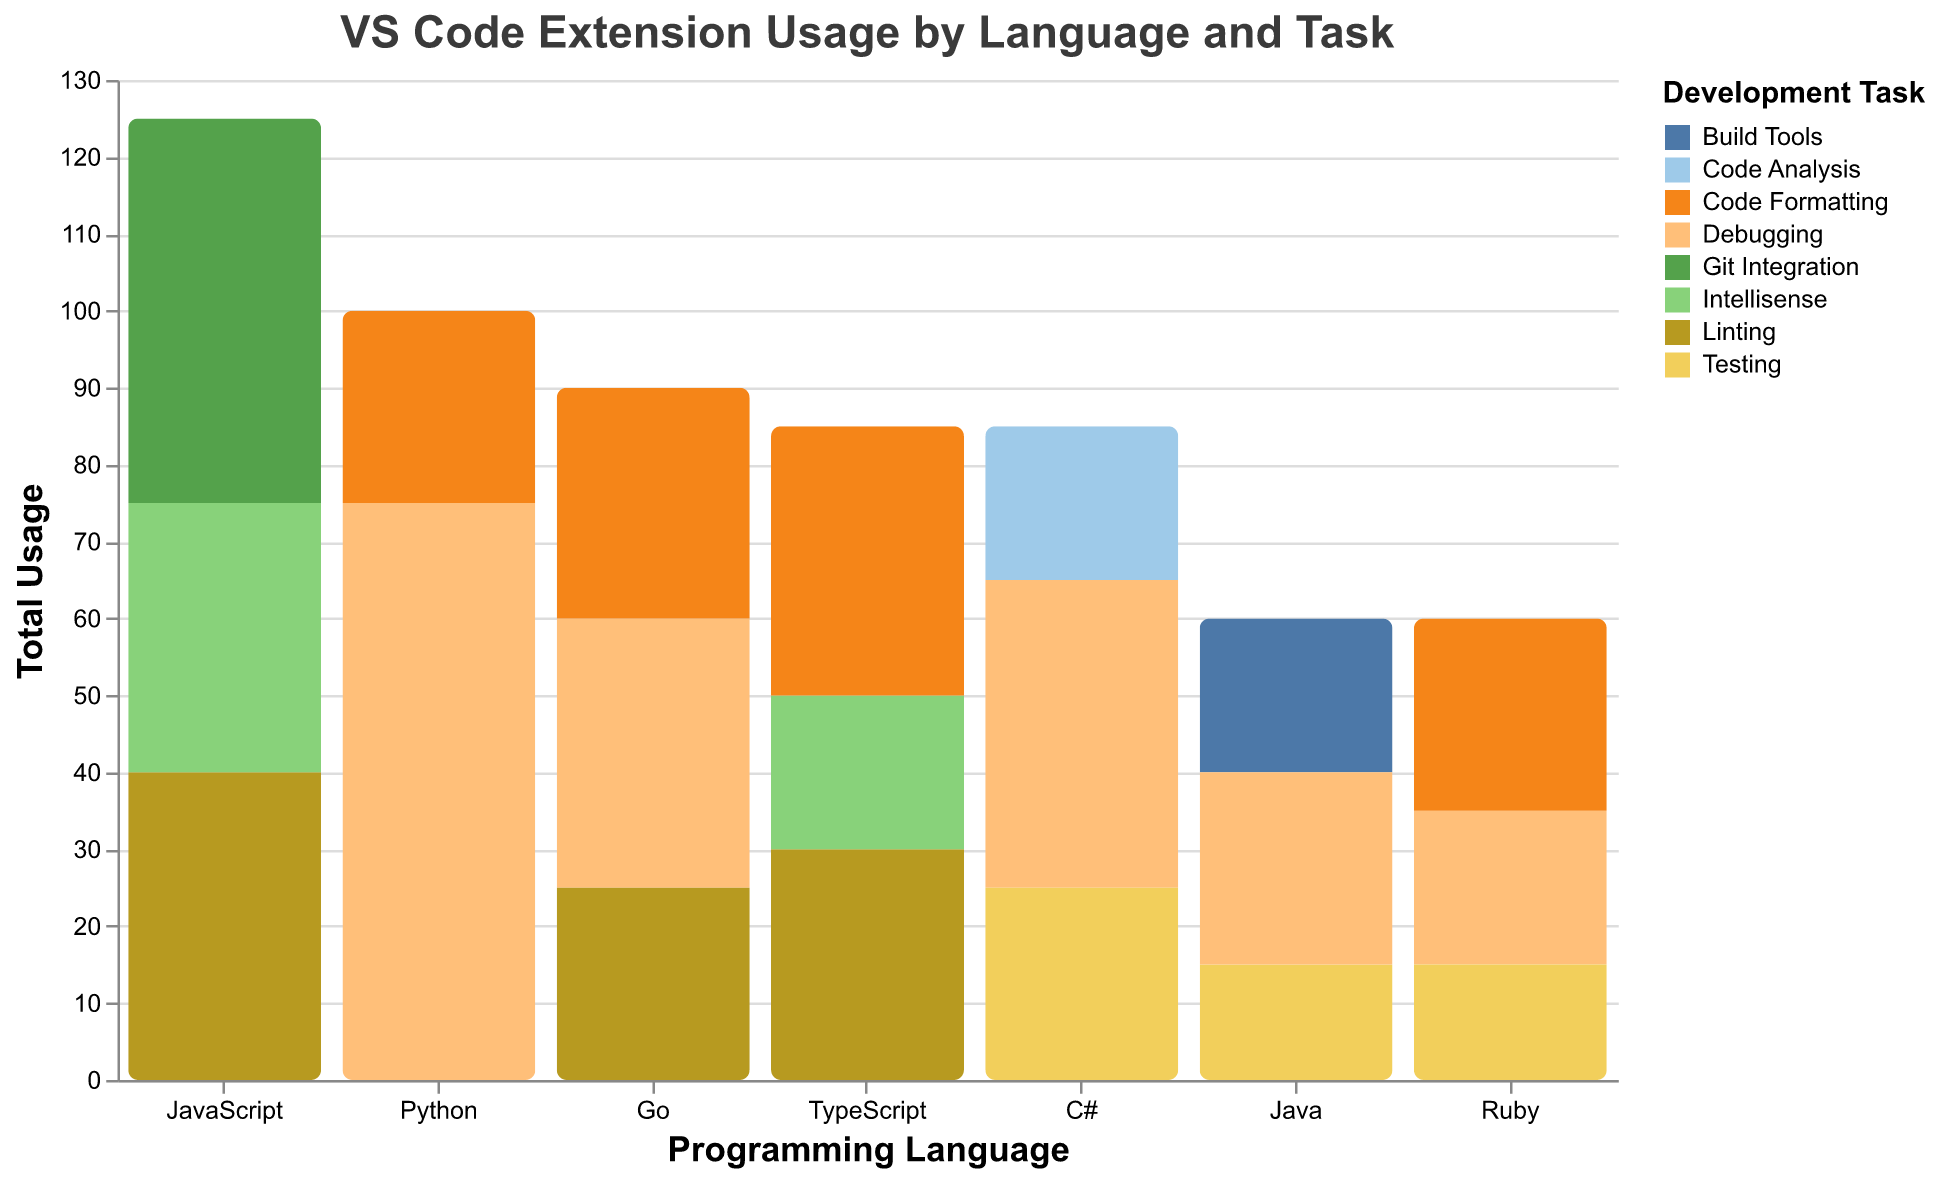What is the total usage of VS Code extensions for Python? To find the total usage for Python extensions, add the usage numbers across different tasks. The usage values for Python are 45 (Debugging - Python), 30 (Debugging - Pylance), and 25 (Code Formatting - Black Formatter). Summing these gives 45 + 30 + 25 = 100.
Answer: 100 Which language has the highest total extension usage? To determine the language with the highest total extension usage, sum the usage for each language and compare. Python has a total of 100, JavaScript has 125, Java has 60, TypeScript has 85, C# has 85, Go has 90, and Ruby has 60. Therefore, JavaScript has the highest total usage with 125.
Answer: JavaScript What is the total usage for linting tasks across all languages? Sum the usage values for all linting tasks, which are: JavaScript - 40 (ESLint), TypeScript - 30 (TSLint), and Go - 25 (golangci-lint). Adding these gives 40 + 30 + 25 = 95.
Answer: 95 Which task contributes the most to the total usage for JavaScript? Look at the usage values for each task associated with JavaScript: Linting - 40, Intellisense - 35, Git Integration - 50. The highest value is for Git Integration with 50.
Answer: Git Integration How does the usage of debugging extensions for Python compare to C#? Compare the total usage of debugging extensions: Python has 45 (Python) + 30 (Pylance) = 75, while C# has 40 (C# for Visual Studio Code). Therefore, Python has higher usage for debugging extensions than C#.
Answer: Python has higher usage Which language has the smallest total usage for testing extensions? Sum the testing usage for each language and find the smallest: Java has 15 (JUnit Runner), C# has 25 (.NET Core Test Explorer), and Ruby has 15 (Ruby Test Explorer). Both Java and Ruby have the smallest testing usage with 15.
Answer: Java and Ruby Is the total usage of intellisense extensions higher in JavaScript or TypeScript? Sum the intellisense usage: JavaScript has 35 (IntelliCode), and TypeScript has 20 (TypeScript Hero). Therefore, JavaScript has higher intellisense usage.
Answer: JavaScript For which language is code formatting the most used task? Compare code formatting usage for each language: Python - 25 (Black Formatter), TypeScript - 35 (Prettier), Go - 30 (gofmt), and Ruby - 25 (Rubocop). TypeScript has the highest usage with 35.
Answer: TypeScript Which language has a wider variety of development tasks based on VS Code extension usage? Count the variety of tasks (categories) for each language:
  - Python: Debugging, Code Formatting
  - JavaScript: Linting, Intellisense, Git Integration
  - Java: Build Tools, Testing, Debugging
  - TypeScript: Linting, Intellisense, Code Formatting
  - C#: Debugging, Testing, Code Analysis
  - Go: Debugging, Code Formatting, Linting
  - Ruby: Debugging, Testing, Code Formatting
  
JavaScript, Java, TypeScript, C#, and Go each cover three different tasks, while Python and Ruby cover two tasks each. Multiple languages have a wide variety of tasks, but JavaScript is highlighted first.
Answer: JavaScript What is the total usage for code analysis extensions? Sum the usage for code analysis tasks: C# has 20 (Roslynator).
Answer: 20 